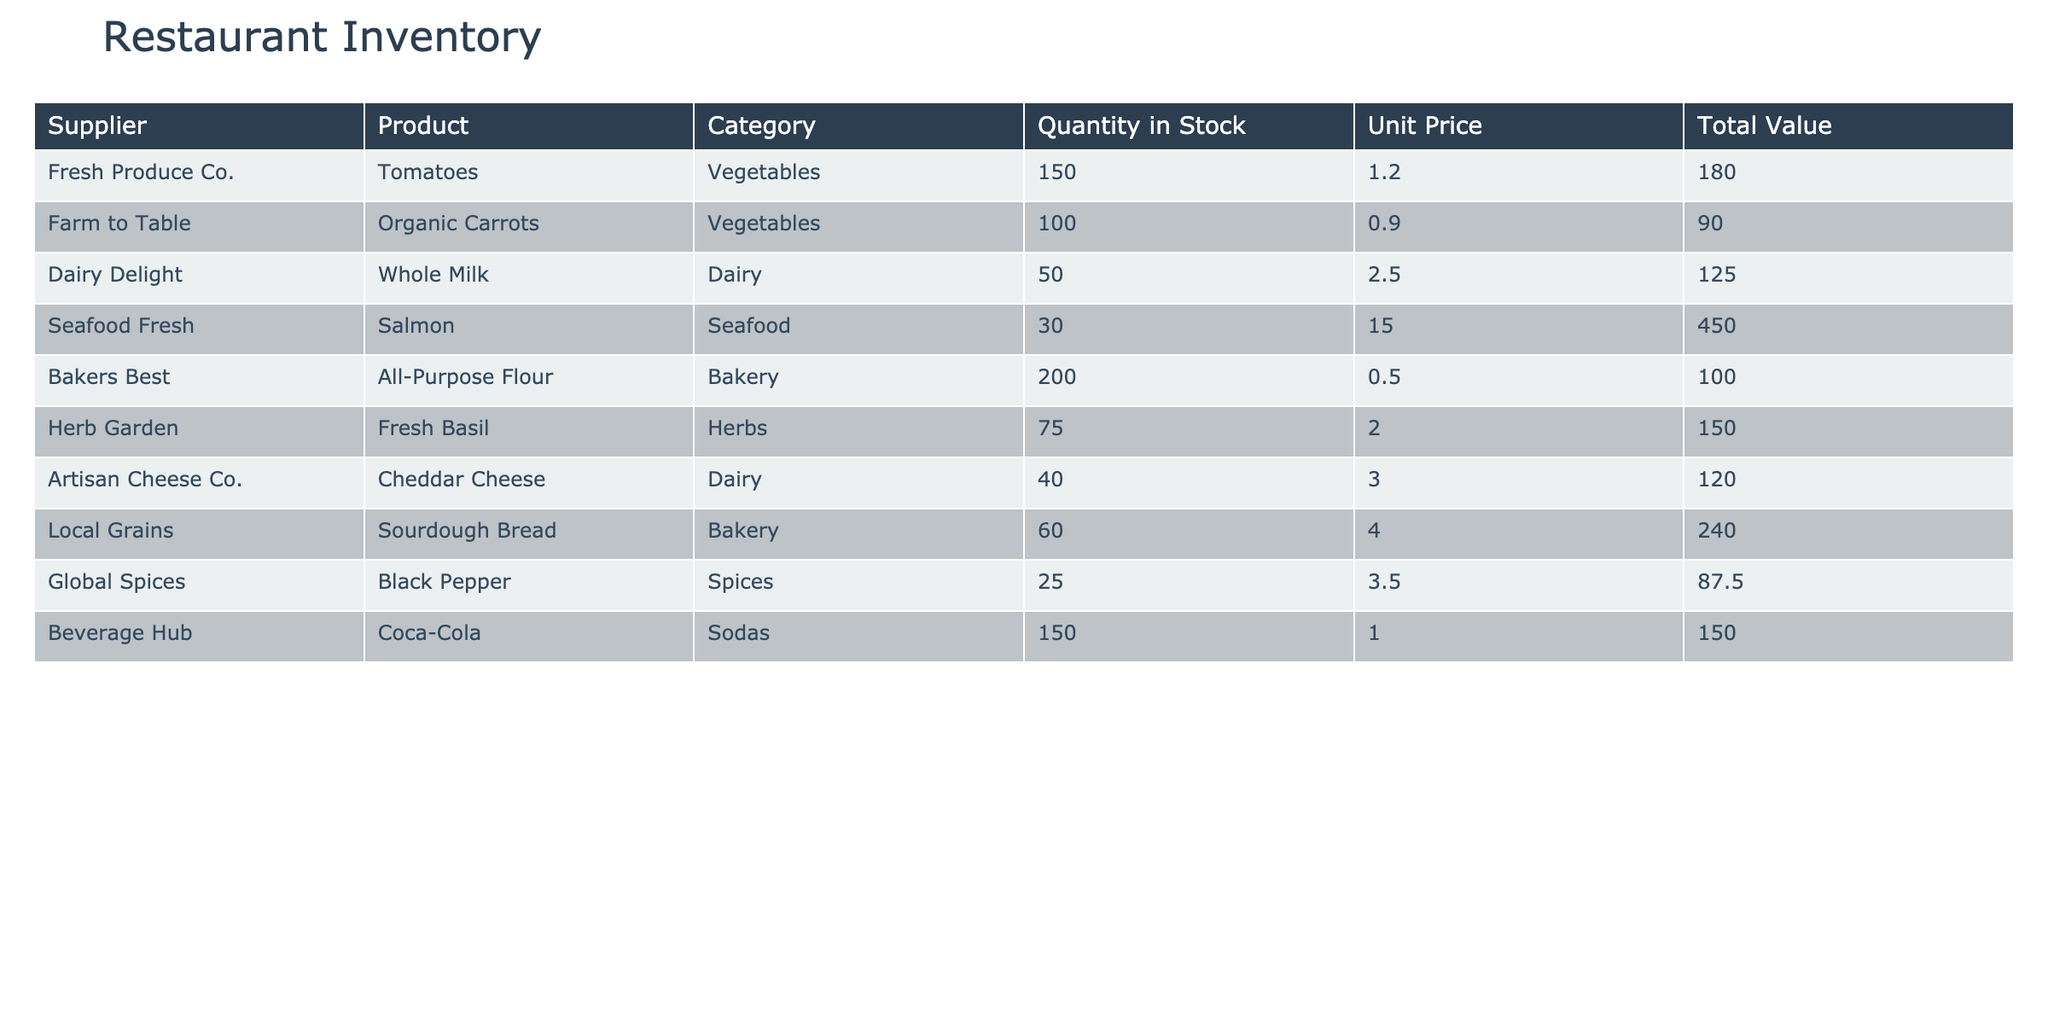What is the total quantity of dairy products in stock? The table lists two dairy products: Whole Milk with a quantity of 50 and Cheddar Cheese with a quantity of 40. Summing these gives 50 + 40 = 90.
Answer: 90 Which supplier has the highest total value of inventory? The total values for each supplier are: Fresh Produce Co. - 180, Farm to Table - 90, Dairy Delight - 125, Seafood Fresh - 450, Bakers Best - 100, Herb Garden - 150, Artisan Cheese Co. - 120, Local Grains - 240, Global Spices - 87.5, Beverage Hub - 150. The highest value is 450 from Seafood Fresh.
Answer: Seafood Fresh Is the quantity of seafood higher than the quantity of vegetables? The quantity of seafood (Salmon) is 30, while the total quantity of vegetables (Tomatoes, Organic Carrots) is 150 + 100 = 250. Since 30 is less than 250, the answer is no.
Answer: No What is the total value of all bakery products? There are two bakery products: All-Purpose Flour with a total value of 100 and Sourdough Bread with a total value of 240. Adding these gives 100 + 240 = 340.
Answer: 340 What is the average unit price of herb products? The only herb product listed is Fresh Basil with a unit price of 2.00. Since there is only one product, the average is simply 2.00 divided by 1, which is 2.00.
Answer: 2.00 Which product has the lowest quantity in stock? Analyzing the quantities in stock: Tomatoes - 150, Organic Carrots - 100, Whole Milk - 50, Salmon - 30, All-Purpose Flour - 200, Fresh Basil - 75, Cheddar Cheese - 40, Sourdough Bread - 60, Black Pepper - 25, Coca-Cola - 150. The lowest quantity is for Black Pepper at 25.
Answer: Black Pepper What is the total value of inventory from all suppliers combined? To find the total value, we sum up all the total values: 180 + 90 + 125 + 450 + 100 + 150 + 120 + 240 + 87.5 + 150, which equals 1,572.5.
Answer: 1,572.5 Are there more than 100 units of any vegetable in stock? The table shows 150 tomatoes and 100 organic carrots; both quantities exceed 100. Therefore, the answer is yes.
Answer: Yes What is the difference in total value between the highest and lowest valued suppliers? The highest total value is 450 (Seafood Fresh) and the lowest is 87.5 (Global Spices). The difference is 450 - 87.5 = 362.5.
Answer: 362.5 